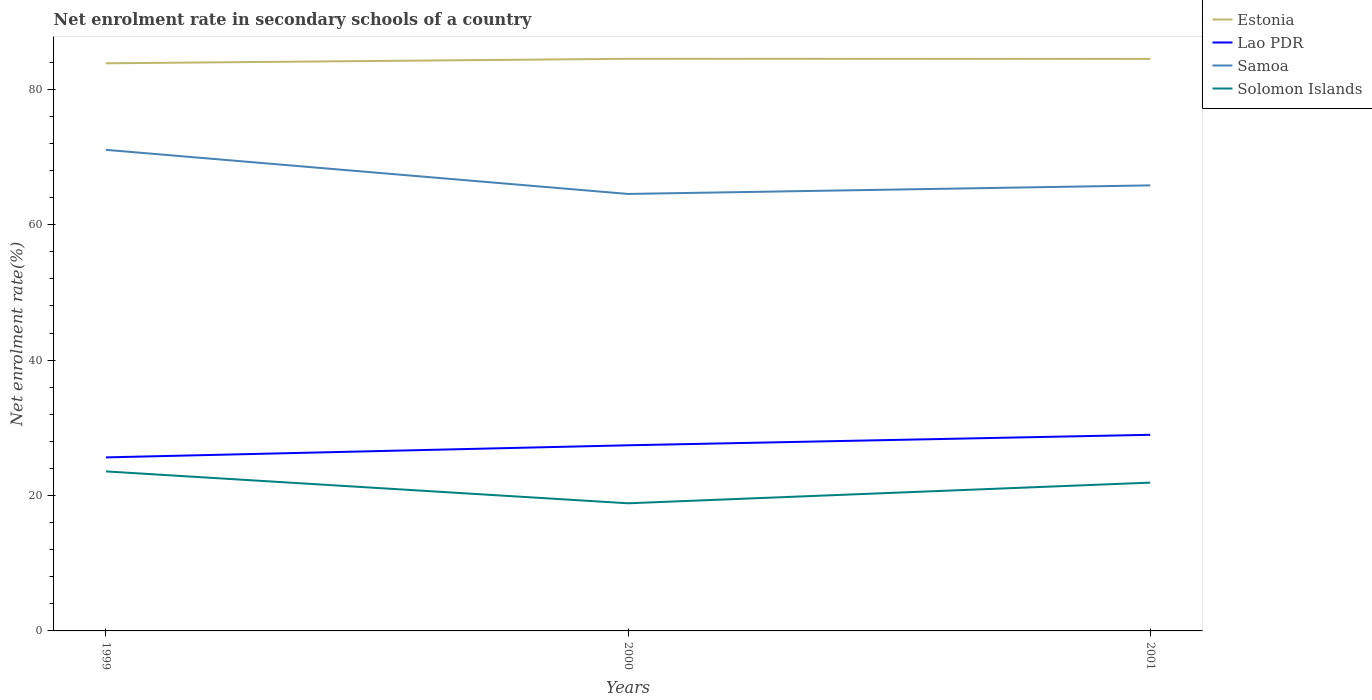Does the line corresponding to Samoa intersect with the line corresponding to Lao PDR?
Give a very brief answer. No. Is the number of lines equal to the number of legend labels?
Provide a succinct answer. Yes. Across all years, what is the maximum net enrolment rate in secondary schools in Solomon Islands?
Ensure brevity in your answer.  18.85. What is the total net enrolment rate in secondary schools in Lao PDR in the graph?
Ensure brevity in your answer.  -3.34. What is the difference between the highest and the second highest net enrolment rate in secondary schools in Samoa?
Make the answer very short. 6.52. How many lines are there?
Your answer should be very brief. 4. Does the graph contain grids?
Ensure brevity in your answer.  No. How many legend labels are there?
Keep it short and to the point. 4. What is the title of the graph?
Keep it short and to the point. Net enrolment rate in secondary schools of a country. Does "Eritrea" appear as one of the legend labels in the graph?
Your answer should be very brief. No. What is the label or title of the Y-axis?
Your answer should be very brief. Net enrolment rate(%). What is the Net enrolment rate(%) in Estonia in 1999?
Your answer should be very brief. 83.84. What is the Net enrolment rate(%) in Lao PDR in 1999?
Provide a succinct answer. 25.63. What is the Net enrolment rate(%) of Samoa in 1999?
Keep it short and to the point. 71.06. What is the Net enrolment rate(%) in Solomon Islands in 1999?
Ensure brevity in your answer.  23.56. What is the Net enrolment rate(%) in Estonia in 2000?
Ensure brevity in your answer.  84.51. What is the Net enrolment rate(%) in Lao PDR in 2000?
Provide a short and direct response. 27.42. What is the Net enrolment rate(%) in Samoa in 2000?
Ensure brevity in your answer.  64.54. What is the Net enrolment rate(%) of Solomon Islands in 2000?
Keep it short and to the point. 18.85. What is the Net enrolment rate(%) in Estonia in 2001?
Give a very brief answer. 84.49. What is the Net enrolment rate(%) in Lao PDR in 2001?
Provide a short and direct response. 28.97. What is the Net enrolment rate(%) of Samoa in 2001?
Give a very brief answer. 65.81. What is the Net enrolment rate(%) in Solomon Islands in 2001?
Give a very brief answer. 21.9. Across all years, what is the maximum Net enrolment rate(%) of Estonia?
Give a very brief answer. 84.51. Across all years, what is the maximum Net enrolment rate(%) in Lao PDR?
Ensure brevity in your answer.  28.97. Across all years, what is the maximum Net enrolment rate(%) of Samoa?
Provide a succinct answer. 71.06. Across all years, what is the maximum Net enrolment rate(%) of Solomon Islands?
Provide a succinct answer. 23.56. Across all years, what is the minimum Net enrolment rate(%) of Estonia?
Your answer should be very brief. 83.84. Across all years, what is the minimum Net enrolment rate(%) of Lao PDR?
Give a very brief answer. 25.63. Across all years, what is the minimum Net enrolment rate(%) of Samoa?
Ensure brevity in your answer.  64.54. Across all years, what is the minimum Net enrolment rate(%) in Solomon Islands?
Make the answer very short. 18.85. What is the total Net enrolment rate(%) of Estonia in the graph?
Your answer should be compact. 252.84. What is the total Net enrolment rate(%) of Lao PDR in the graph?
Provide a short and direct response. 82.02. What is the total Net enrolment rate(%) in Samoa in the graph?
Offer a very short reply. 201.42. What is the total Net enrolment rate(%) of Solomon Islands in the graph?
Make the answer very short. 64.32. What is the difference between the Net enrolment rate(%) of Estonia in 1999 and that in 2000?
Provide a short and direct response. -0.66. What is the difference between the Net enrolment rate(%) in Lao PDR in 1999 and that in 2000?
Ensure brevity in your answer.  -1.79. What is the difference between the Net enrolment rate(%) of Samoa in 1999 and that in 2000?
Make the answer very short. 6.52. What is the difference between the Net enrolment rate(%) of Solomon Islands in 1999 and that in 2000?
Provide a succinct answer. 4.71. What is the difference between the Net enrolment rate(%) in Estonia in 1999 and that in 2001?
Offer a terse response. -0.65. What is the difference between the Net enrolment rate(%) in Lao PDR in 1999 and that in 2001?
Your answer should be very brief. -3.34. What is the difference between the Net enrolment rate(%) in Samoa in 1999 and that in 2001?
Keep it short and to the point. 5.25. What is the difference between the Net enrolment rate(%) of Solomon Islands in 1999 and that in 2001?
Keep it short and to the point. 1.66. What is the difference between the Net enrolment rate(%) of Estonia in 2000 and that in 2001?
Keep it short and to the point. 0.02. What is the difference between the Net enrolment rate(%) in Lao PDR in 2000 and that in 2001?
Your answer should be compact. -1.55. What is the difference between the Net enrolment rate(%) in Samoa in 2000 and that in 2001?
Your answer should be compact. -1.27. What is the difference between the Net enrolment rate(%) of Solomon Islands in 2000 and that in 2001?
Ensure brevity in your answer.  -3.05. What is the difference between the Net enrolment rate(%) in Estonia in 1999 and the Net enrolment rate(%) in Lao PDR in 2000?
Provide a short and direct response. 56.42. What is the difference between the Net enrolment rate(%) of Estonia in 1999 and the Net enrolment rate(%) of Samoa in 2000?
Your answer should be compact. 19.3. What is the difference between the Net enrolment rate(%) of Estonia in 1999 and the Net enrolment rate(%) of Solomon Islands in 2000?
Your answer should be very brief. 64.99. What is the difference between the Net enrolment rate(%) of Lao PDR in 1999 and the Net enrolment rate(%) of Samoa in 2000?
Your response must be concise. -38.91. What is the difference between the Net enrolment rate(%) of Lao PDR in 1999 and the Net enrolment rate(%) of Solomon Islands in 2000?
Offer a very short reply. 6.78. What is the difference between the Net enrolment rate(%) of Samoa in 1999 and the Net enrolment rate(%) of Solomon Islands in 2000?
Provide a succinct answer. 52.21. What is the difference between the Net enrolment rate(%) of Estonia in 1999 and the Net enrolment rate(%) of Lao PDR in 2001?
Give a very brief answer. 54.87. What is the difference between the Net enrolment rate(%) in Estonia in 1999 and the Net enrolment rate(%) in Samoa in 2001?
Your answer should be compact. 18.03. What is the difference between the Net enrolment rate(%) of Estonia in 1999 and the Net enrolment rate(%) of Solomon Islands in 2001?
Offer a very short reply. 61.94. What is the difference between the Net enrolment rate(%) in Lao PDR in 1999 and the Net enrolment rate(%) in Samoa in 2001?
Provide a short and direct response. -40.18. What is the difference between the Net enrolment rate(%) in Lao PDR in 1999 and the Net enrolment rate(%) in Solomon Islands in 2001?
Make the answer very short. 3.73. What is the difference between the Net enrolment rate(%) of Samoa in 1999 and the Net enrolment rate(%) of Solomon Islands in 2001?
Offer a terse response. 49.16. What is the difference between the Net enrolment rate(%) in Estonia in 2000 and the Net enrolment rate(%) in Lao PDR in 2001?
Offer a terse response. 55.54. What is the difference between the Net enrolment rate(%) in Estonia in 2000 and the Net enrolment rate(%) in Samoa in 2001?
Provide a short and direct response. 18.7. What is the difference between the Net enrolment rate(%) in Estonia in 2000 and the Net enrolment rate(%) in Solomon Islands in 2001?
Your answer should be very brief. 62.6. What is the difference between the Net enrolment rate(%) of Lao PDR in 2000 and the Net enrolment rate(%) of Samoa in 2001?
Your answer should be very brief. -38.39. What is the difference between the Net enrolment rate(%) of Lao PDR in 2000 and the Net enrolment rate(%) of Solomon Islands in 2001?
Offer a terse response. 5.52. What is the difference between the Net enrolment rate(%) of Samoa in 2000 and the Net enrolment rate(%) of Solomon Islands in 2001?
Your answer should be very brief. 42.64. What is the average Net enrolment rate(%) in Estonia per year?
Keep it short and to the point. 84.28. What is the average Net enrolment rate(%) of Lao PDR per year?
Your answer should be compact. 27.34. What is the average Net enrolment rate(%) of Samoa per year?
Ensure brevity in your answer.  67.14. What is the average Net enrolment rate(%) in Solomon Islands per year?
Offer a very short reply. 21.44. In the year 1999, what is the difference between the Net enrolment rate(%) in Estonia and Net enrolment rate(%) in Lao PDR?
Keep it short and to the point. 58.21. In the year 1999, what is the difference between the Net enrolment rate(%) of Estonia and Net enrolment rate(%) of Samoa?
Provide a succinct answer. 12.78. In the year 1999, what is the difference between the Net enrolment rate(%) in Estonia and Net enrolment rate(%) in Solomon Islands?
Make the answer very short. 60.28. In the year 1999, what is the difference between the Net enrolment rate(%) of Lao PDR and Net enrolment rate(%) of Samoa?
Your response must be concise. -45.43. In the year 1999, what is the difference between the Net enrolment rate(%) of Lao PDR and Net enrolment rate(%) of Solomon Islands?
Your response must be concise. 2.07. In the year 1999, what is the difference between the Net enrolment rate(%) in Samoa and Net enrolment rate(%) in Solomon Islands?
Offer a very short reply. 47.5. In the year 2000, what is the difference between the Net enrolment rate(%) in Estonia and Net enrolment rate(%) in Lao PDR?
Ensure brevity in your answer.  57.09. In the year 2000, what is the difference between the Net enrolment rate(%) in Estonia and Net enrolment rate(%) in Samoa?
Make the answer very short. 19.96. In the year 2000, what is the difference between the Net enrolment rate(%) of Estonia and Net enrolment rate(%) of Solomon Islands?
Provide a succinct answer. 65.65. In the year 2000, what is the difference between the Net enrolment rate(%) of Lao PDR and Net enrolment rate(%) of Samoa?
Your answer should be compact. -37.12. In the year 2000, what is the difference between the Net enrolment rate(%) in Lao PDR and Net enrolment rate(%) in Solomon Islands?
Keep it short and to the point. 8.57. In the year 2000, what is the difference between the Net enrolment rate(%) of Samoa and Net enrolment rate(%) of Solomon Islands?
Provide a succinct answer. 45.69. In the year 2001, what is the difference between the Net enrolment rate(%) of Estonia and Net enrolment rate(%) of Lao PDR?
Make the answer very short. 55.52. In the year 2001, what is the difference between the Net enrolment rate(%) in Estonia and Net enrolment rate(%) in Samoa?
Offer a terse response. 18.68. In the year 2001, what is the difference between the Net enrolment rate(%) in Estonia and Net enrolment rate(%) in Solomon Islands?
Your response must be concise. 62.58. In the year 2001, what is the difference between the Net enrolment rate(%) in Lao PDR and Net enrolment rate(%) in Samoa?
Your response must be concise. -36.84. In the year 2001, what is the difference between the Net enrolment rate(%) in Lao PDR and Net enrolment rate(%) in Solomon Islands?
Offer a terse response. 7.06. In the year 2001, what is the difference between the Net enrolment rate(%) in Samoa and Net enrolment rate(%) in Solomon Islands?
Offer a very short reply. 43.91. What is the ratio of the Net enrolment rate(%) of Estonia in 1999 to that in 2000?
Offer a very short reply. 0.99. What is the ratio of the Net enrolment rate(%) in Lao PDR in 1999 to that in 2000?
Make the answer very short. 0.93. What is the ratio of the Net enrolment rate(%) of Samoa in 1999 to that in 2000?
Your answer should be very brief. 1.1. What is the ratio of the Net enrolment rate(%) in Solomon Islands in 1999 to that in 2000?
Give a very brief answer. 1.25. What is the ratio of the Net enrolment rate(%) of Lao PDR in 1999 to that in 2001?
Provide a short and direct response. 0.88. What is the ratio of the Net enrolment rate(%) in Samoa in 1999 to that in 2001?
Provide a succinct answer. 1.08. What is the ratio of the Net enrolment rate(%) of Solomon Islands in 1999 to that in 2001?
Provide a short and direct response. 1.08. What is the ratio of the Net enrolment rate(%) of Estonia in 2000 to that in 2001?
Give a very brief answer. 1. What is the ratio of the Net enrolment rate(%) in Lao PDR in 2000 to that in 2001?
Keep it short and to the point. 0.95. What is the ratio of the Net enrolment rate(%) of Samoa in 2000 to that in 2001?
Your response must be concise. 0.98. What is the ratio of the Net enrolment rate(%) of Solomon Islands in 2000 to that in 2001?
Your answer should be compact. 0.86. What is the difference between the highest and the second highest Net enrolment rate(%) in Estonia?
Ensure brevity in your answer.  0.02. What is the difference between the highest and the second highest Net enrolment rate(%) of Lao PDR?
Keep it short and to the point. 1.55. What is the difference between the highest and the second highest Net enrolment rate(%) in Samoa?
Give a very brief answer. 5.25. What is the difference between the highest and the second highest Net enrolment rate(%) in Solomon Islands?
Your answer should be compact. 1.66. What is the difference between the highest and the lowest Net enrolment rate(%) of Estonia?
Make the answer very short. 0.66. What is the difference between the highest and the lowest Net enrolment rate(%) of Lao PDR?
Provide a succinct answer. 3.34. What is the difference between the highest and the lowest Net enrolment rate(%) in Samoa?
Offer a very short reply. 6.52. What is the difference between the highest and the lowest Net enrolment rate(%) in Solomon Islands?
Make the answer very short. 4.71. 